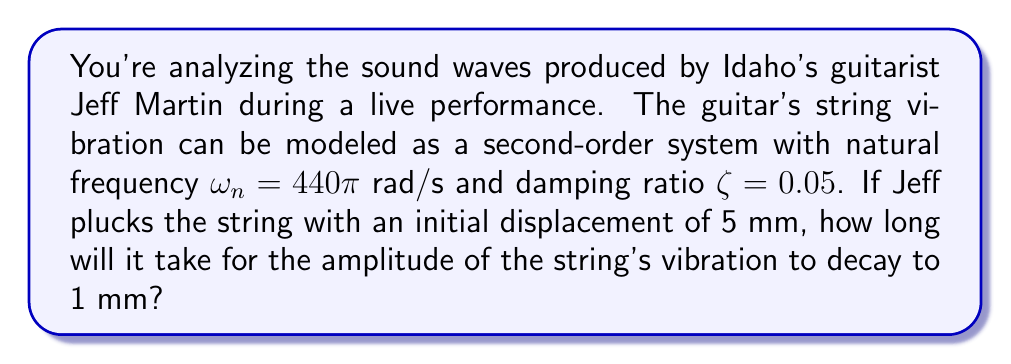What is the answer to this math problem? To solve this problem, we need to analyze the time-domain response of the second-order system representing the guitar string vibration. The system is underdamped since $\zeta < 1$.

1) For an underdamped second-order system, the time-domain response is given by:

   $$x(t) = Ae^{-\zeta\omega_n t} \sin(\omega_d t + \phi)$$

   where $A$ is the initial amplitude, $\omega_d = \omega_n\sqrt{1-\zeta^2}$ is the damped natural frequency, and $\phi$ is the phase angle.

2) We're interested in the envelope of this oscillation, which is given by:

   $$x_{envelope}(t) = Ae^{-\zeta\omega_n t}$$

3) We want to find the time $t$ when the amplitude decays from 5 mm to 1 mm. We can express this as:

   $$1 = 5e^{-\zeta\omega_n t}$$

4) Taking the natural logarithm of both sides:

   $$\ln(1/5) = -\zeta\omega_n t$$

5) Solving for $t$:

   $$t = -\frac{\ln(1/5)}{\zeta\omega_n} = \frac{\ln(5)}{\zeta\omega_n}$$

6) Substituting the given values:

   $$t = \frac{\ln(5)}{0.05 \cdot 440\pi} \approx 0.0231 \text{ seconds}$$

Therefore, it will take approximately 0.0231 seconds for the amplitude to decay from 5 mm to 1 mm.
Answer: 0.0231 seconds 